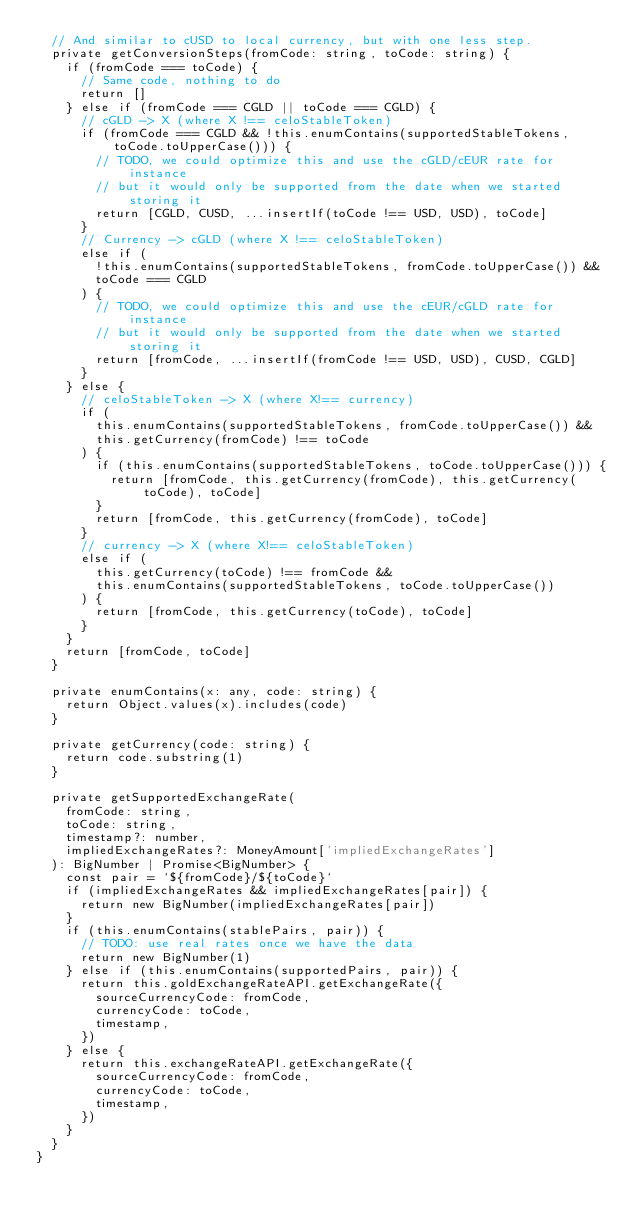<code> <loc_0><loc_0><loc_500><loc_500><_TypeScript_>  // And similar to cUSD to local currency, but with one less step.
  private getConversionSteps(fromCode: string, toCode: string) {
    if (fromCode === toCode) {
      // Same code, nothing to do
      return []
    } else if (fromCode === CGLD || toCode === CGLD) {
      // cGLD -> X (where X !== celoStableToken)
      if (fromCode === CGLD && !this.enumContains(supportedStableTokens, toCode.toUpperCase())) {
        // TODO, we could optimize this and use the cGLD/cEUR rate for instance
        // but it would only be supported from the date when we started storing it
        return [CGLD, CUSD, ...insertIf(toCode !== USD, USD), toCode]
      }
      // Currency -> cGLD (where X !== celoStableToken)
      else if (
        !this.enumContains(supportedStableTokens, fromCode.toUpperCase()) &&
        toCode === CGLD
      ) {
        // TODO, we could optimize this and use the cEUR/cGLD rate for instance
        // but it would only be supported from the date when we started storing it
        return [fromCode, ...insertIf(fromCode !== USD, USD), CUSD, CGLD]
      }
    } else {
      // celoStableToken -> X (where X!== currency)
      if (
        this.enumContains(supportedStableTokens, fromCode.toUpperCase()) &&
        this.getCurrency(fromCode) !== toCode
      ) {
        if (this.enumContains(supportedStableTokens, toCode.toUpperCase())) {
          return [fromCode, this.getCurrency(fromCode), this.getCurrency(toCode), toCode]
        }
        return [fromCode, this.getCurrency(fromCode), toCode]
      }
      // currency -> X (where X!== celoStableToken)
      else if (
        this.getCurrency(toCode) !== fromCode &&
        this.enumContains(supportedStableTokens, toCode.toUpperCase())
      ) {
        return [fromCode, this.getCurrency(toCode), toCode]
      }
    }
    return [fromCode, toCode]
  }

  private enumContains(x: any, code: string) {
    return Object.values(x).includes(code)
  }

  private getCurrency(code: string) {
    return code.substring(1)
  }

  private getSupportedExchangeRate(
    fromCode: string,
    toCode: string,
    timestamp?: number,
    impliedExchangeRates?: MoneyAmount['impliedExchangeRates']
  ): BigNumber | Promise<BigNumber> {
    const pair = `${fromCode}/${toCode}`
    if (impliedExchangeRates && impliedExchangeRates[pair]) {
      return new BigNumber(impliedExchangeRates[pair])
    }
    if (this.enumContains(stablePairs, pair)) {
      // TODO: use real rates once we have the data
      return new BigNumber(1)
    } else if (this.enumContains(supportedPairs, pair)) {
      return this.goldExchangeRateAPI.getExchangeRate({
        sourceCurrencyCode: fromCode,
        currencyCode: toCode,
        timestamp,
      })
    } else {
      return this.exchangeRateAPI.getExchangeRate({
        sourceCurrencyCode: fromCode,
        currencyCode: toCode,
        timestamp,
      })
    }
  }
}
</code> 